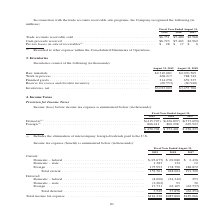From Jabil Circuit's financial document, What types of income (loss) before income tax expense is provided by the table? The document shows two values: Domestic and Foreign. From the document: "Domestic (1) . $(415,707) $(426,897) $(373,690) Foreign (1) . 866,411 800,298 629,923 Domestic (1) . $(415,707) $(426,897) $(373,690) Foreign (1) . 86..." Also, What was the Domestic income (loss) in 2019? According to the financial document, $(415,707) (in thousands). The relevant text states: "Domestic (1) . $(415,707) $(426,897) $(373,690) Foreign (1) . 866,411 800,298 629,923..." Also, What was the foreign income (loss) in 2018? According to the financial document, 800,298 (in thousands). The relevant text states: ",707) $(426,897) $(373,690) Foreign (1) . 866,411 800,298 629,923..." Also, can you calculate: What was the change in Foreign income (loss) between 2018 and 2019? Based on the calculation: 866,411-800,298, the result is 66113 (in thousands). This is based on the information: ". $(415,707) $(426,897) $(373,690) Foreign (1) . 866,411 800,298 629,923 ,707) $(426,897) $(373,690) Foreign (1) . 866,411 800,298 629,923..." The key data points involved are: 800,298, 866,411. Also, How many years did Foreign income (loss) exceed $800,000 thousand? Counting the relevant items in the document: 2019, 2018, I find 2 instances. The key data points involved are: 2018, 2019. Also, can you calculate: What was the percentage change in total income (loss) between 2017 and 2018? To answer this question, I need to perform calculations using the financial data. The calculation is: ($373,401-$256,233)/$256,233, which equals 45.73 (percentage). This is based on the information: "$ 450,704 $ 373,401 $ 256,233 $ 450,704 $ 373,401 $ 256,233..." The key data points involved are: 256,233, 373,401. 